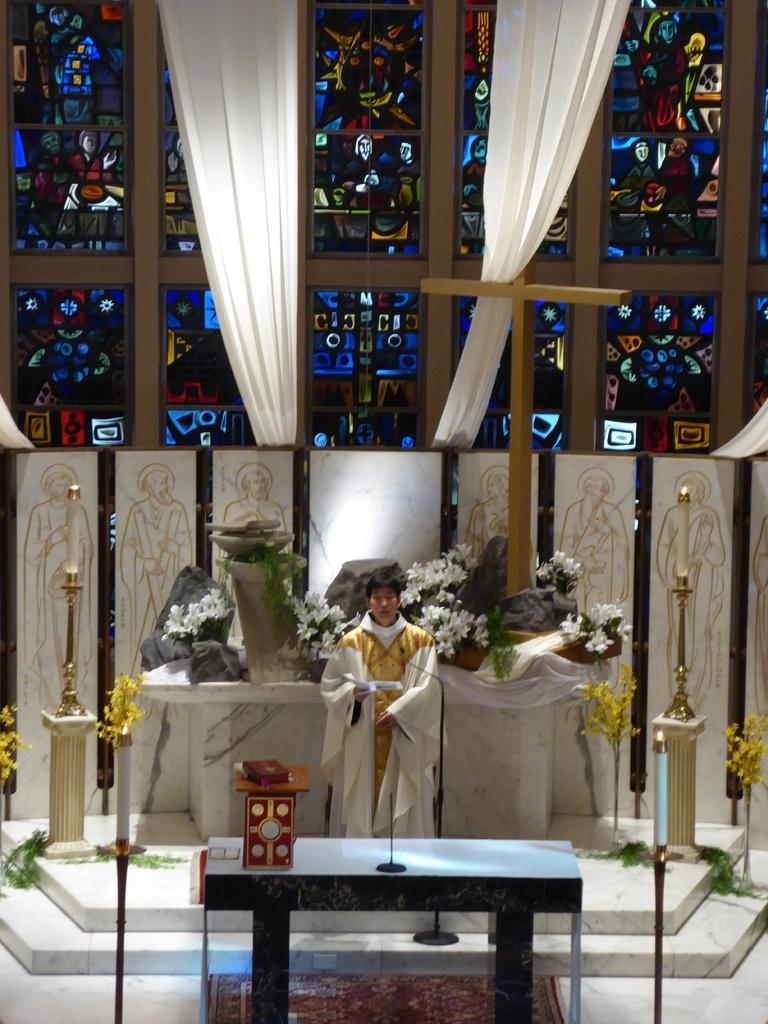Please provide a concise description of this image. In this image, we can see a person is standing and holding a book. Here we can see table, few things and objects are placed on it. Here there is a floor, stairs, rods, pillars, candles, plants. Background there are few curtains, holy cross, glass. 